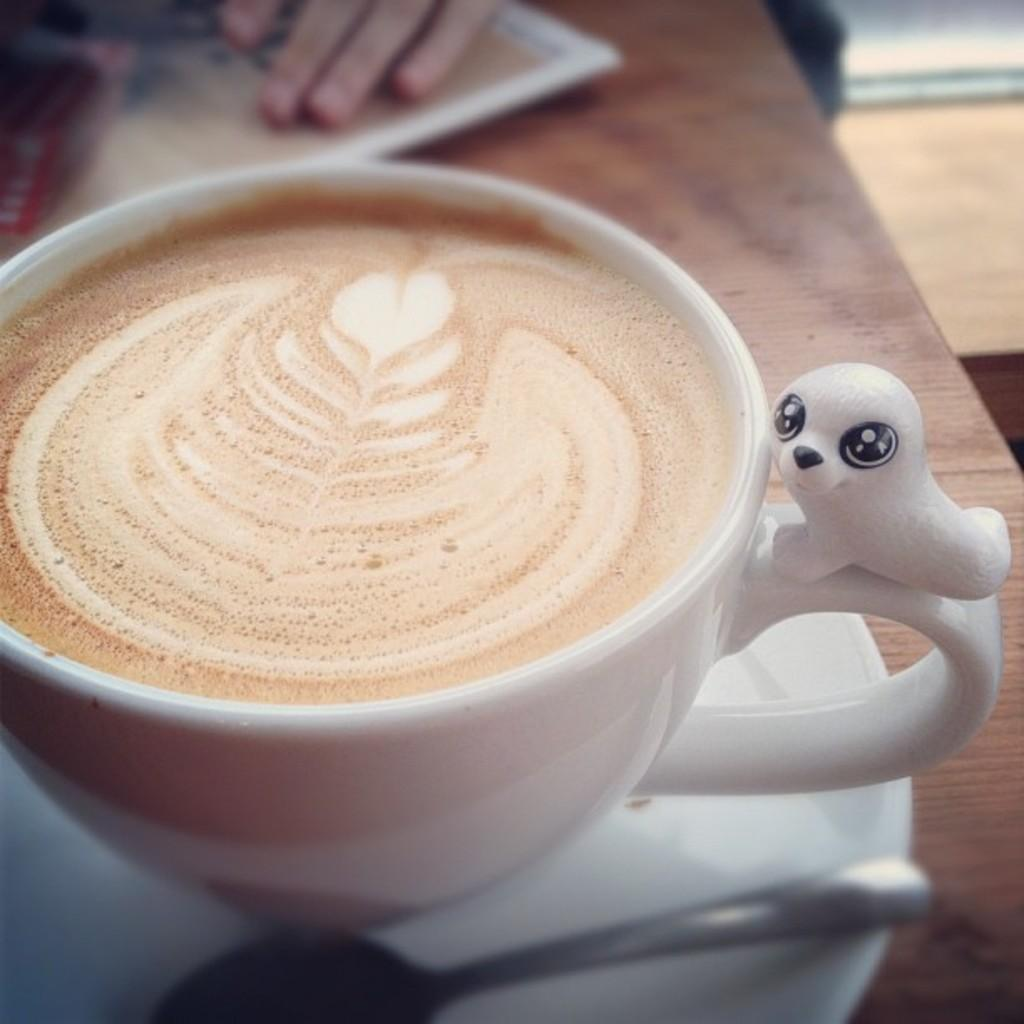What is present on the table in the image? There is a coffee cup in the image. Where is the coffee cup located? The coffee cup is placed on a table. Are there any fairies hiding in the drawer in the image? There is no drawer or fairies present in the image; it only features a coffee cup placed on a table. 